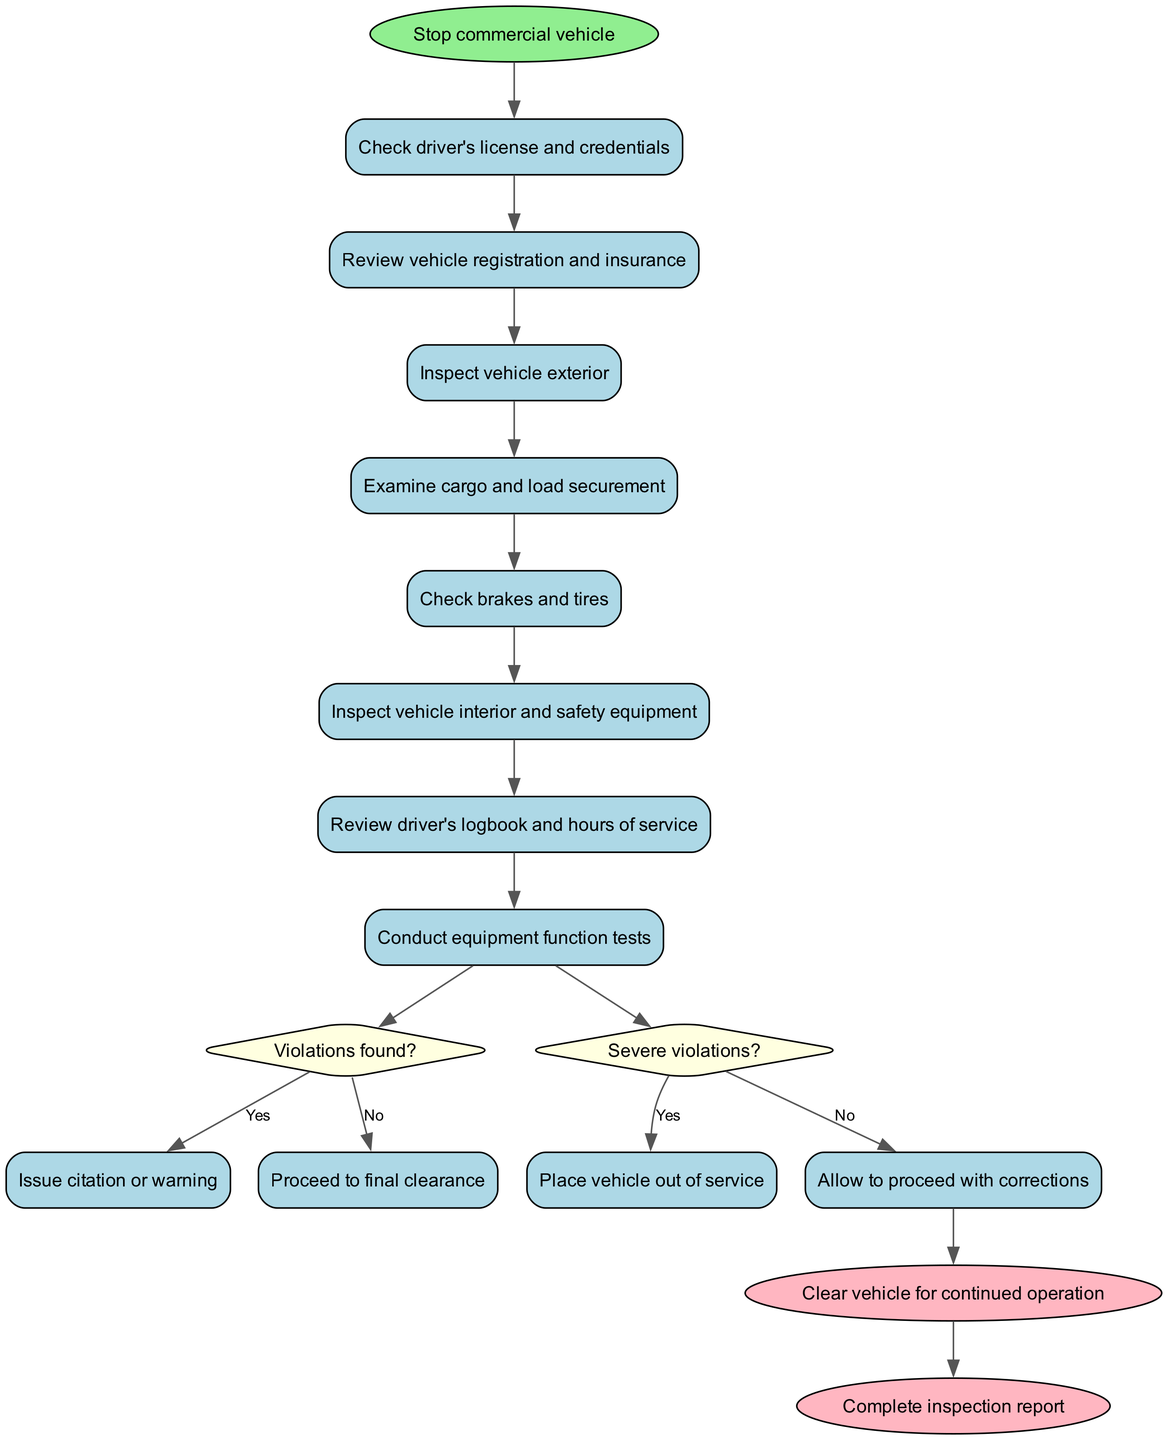What is the first activity performed after stopping the commercial vehicle? The diagram starts with the initial node labeled 'Stop commercial vehicle', followed by the first activity, which is 'Check driver's license and credentials'.
Answer: Check driver's license and credentials How many decision nodes are present in the diagram? The diagram contains two decision nodes: one about violations found and another regarding the severity of those violations.
Answer: 2 What is the final action taken in the inspection process? The final nodes in the diagram indicate two actions: 'Clear vehicle for continued operation' and 'Complete inspection report'. The final action taken is clearing the vehicle.
Answer: Clear vehicle for continued operation What happens if severe violations are found? According to the decision node for severe violations, if 'Yes' the action taken is to 'Place vehicle out of service'.
Answer: Place vehicle out of service Which activity comes before inspecting the vehicle interior? Reviewing the driver's logbook and hours of service is the activity that comes immediately before inspecting the vehicle interior, as seen in the sequence of activities listed.
Answer: Review driver's logbook and hours of service 